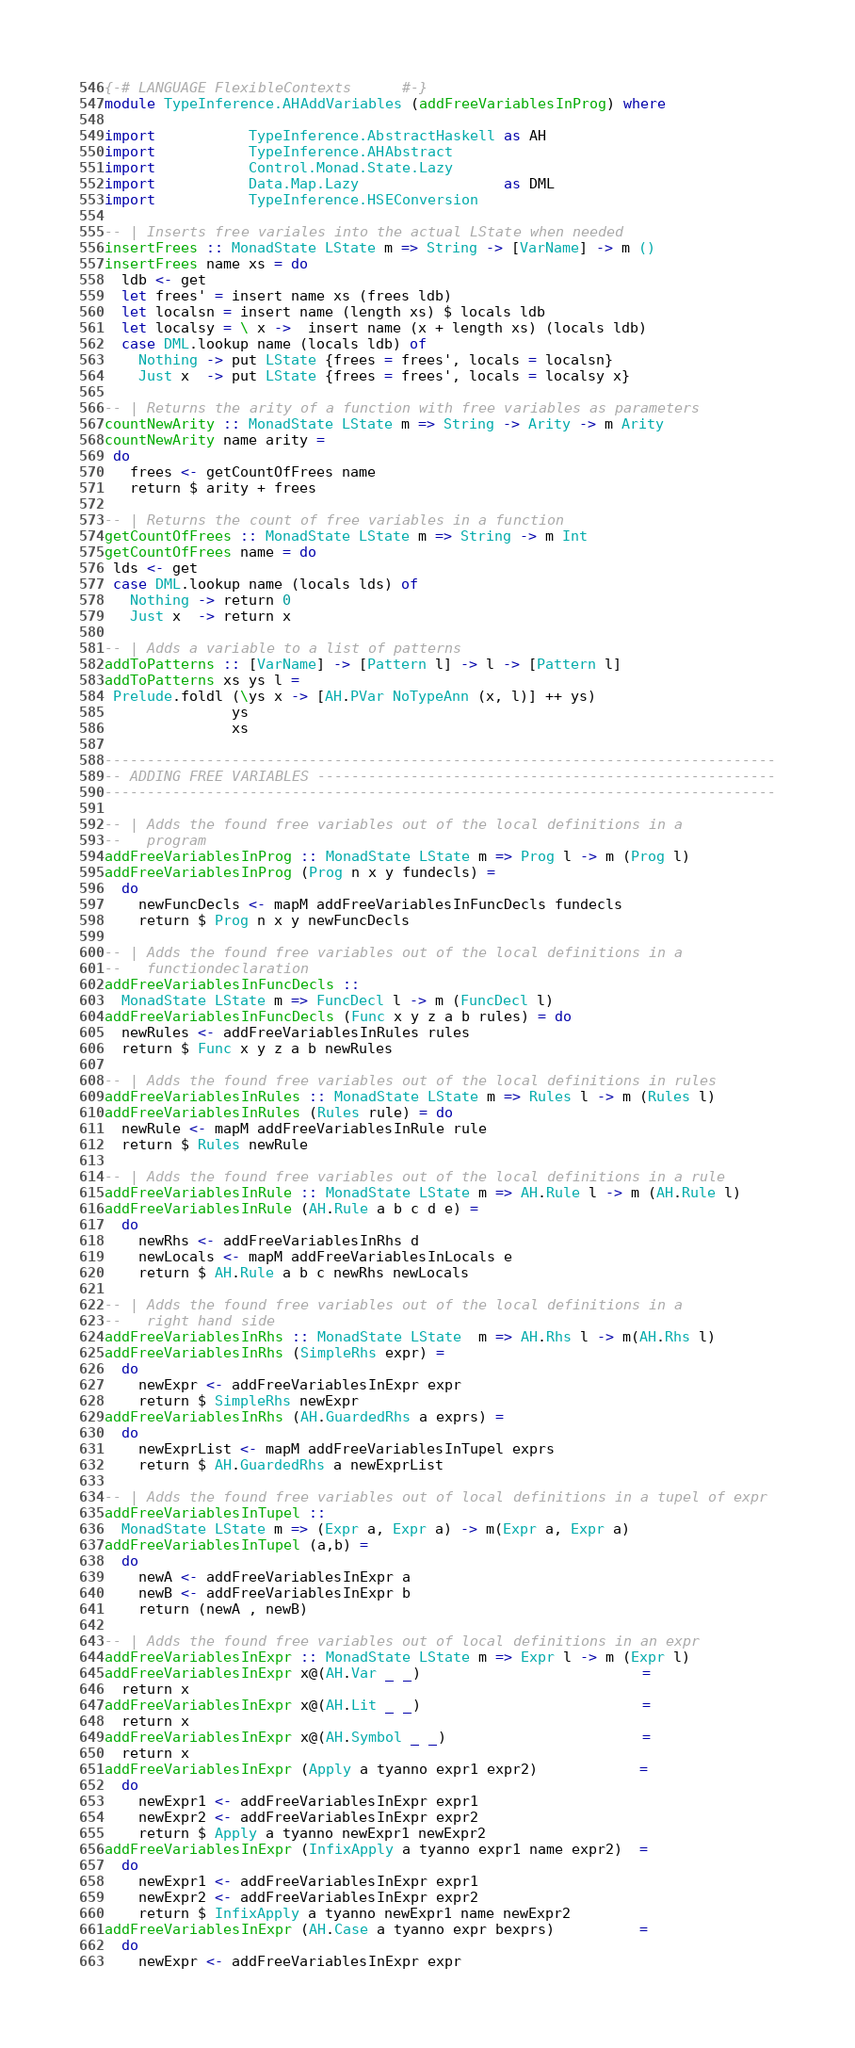Convert code to text. <code><loc_0><loc_0><loc_500><loc_500><_Haskell_>{-# LANGUAGE FlexibleContexts      #-}
module TypeInference.AHAddVariables (addFreeVariablesInProg) where

import           TypeInference.AbstractHaskell as AH
import           TypeInference.AHAbstract
import           Control.Monad.State.Lazy
import           Data.Map.Lazy                 as DML
import           TypeInference.HSEConversion

-- | Inserts free variales into the actual LState when needed
insertFrees :: MonadState LState m => String -> [VarName] -> m ()
insertFrees name xs = do
  ldb <- get
  let frees' = insert name xs (frees ldb)
  let localsn = insert name (length xs) $ locals ldb
  let localsy = \ x ->  insert name (x + length xs) (locals ldb)
  case DML.lookup name (locals ldb) of
    Nothing -> put LState {frees = frees', locals = localsn}
    Just x  -> put LState {frees = frees', locals = localsy x}

-- | Returns the arity of a function with free variables as parameters
countNewArity :: MonadState LState m => String -> Arity -> m Arity
countNewArity name arity =
 do
   frees <- getCountOfFrees name
   return $ arity + frees

-- | Returns the count of free variables in a function
getCountOfFrees :: MonadState LState m => String -> m Int
getCountOfFrees name = do
 lds <- get
 case DML.lookup name (locals lds) of
   Nothing -> return 0
   Just x  -> return x

-- | Adds a variable to a list of patterns
addToPatterns :: [VarName] -> [Pattern l] -> l -> [Pattern l]
addToPatterns xs ys l =
 Prelude.foldl (\ys x -> [AH.PVar NoTypeAnn (x, l)] ++ ys)
               ys
               xs

-------------------------------------------------------------------------------
-- ADDING FREE VARIABLES ------------------------------------------------------
-------------------------------------------------------------------------------

-- | Adds the found free variables out of the local definitions in a
--   program
addFreeVariablesInProg :: MonadState LState m => Prog l -> m (Prog l)
addFreeVariablesInProg (Prog n x y fundecls) =
  do
    newFuncDecls <- mapM addFreeVariablesInFuncDecls fundecls
    return $ Prog n x y newFuncDecls

-- | Adds the found free variables out of the local definitions in a
--   functiondeclaration
addFreeVariablesInFuncDecls ::
  MonadState LState m => FuncDecl l -> m (FuncDecl l)
addFreeVariablesInFuncDecls (Func x y z a b rules) = do
  newRules <- addFreeVariablesInRules rules
  return $ Func x y z a b newRules

-- | Adds the found free variables out of the local definitions in rules
addFreeVariablesInRules :: MonadState LState m => Rules l -> m (Rules l)
addFreeVariablesInRules (Rules rule) = do
  newRule <- mapM addFreeVariablesInRule rule
  return $ Rules newRule

-- | Adds the found free variables out of the local definitions in a rule
addFreeVariablesInRule :: MonadState LState m => AH.Rule l -> m (AH.Rule l)
addFreeVariablesInRule (AH.Rule a b c d e) =
  do
    newRhs <- addFreeVariablesInRhs d
    newLocals <- mapM addFreeVariablesInLocals e
    return $ AH.Rule a b c newRhs newLocals

-- | Adds the found free variables out of the local definitions in a
--   right hand side
addFreeVariablesInRhs :: MonadState LState  m => AH.Rhs l -> m(AH.Rhs l)
addFreeVariablesInRhs (SimpleRhs expr) =
  do
    newExpr <- addFreeVariablesInExpr expr
    return $ SimpleRhs newExpr
addFreeVariablesInRhs (AH.GuardedRhs a exprs) =
  do
    newExprList <- mapM addFreeVariablesInTupel exprs
    return $ AH.GuardedRhs a newExprList

-- | Adds the found free variables out of local definitions in a tupel of expr
addFreeVariablesInTupel ::
  MonadState LState m => (Expr a, Expr a) -> m(Expr a, Expr a)
addFreeVariablesInTupel (a,b) =
  do
    newA <- addFreeVariablesInExpr a
    newB <- addFreeVariablesInExpr b
    return (newA , newB)

-- | Adds the found free variables out of local definitions in an expr
addFreeVariablesInExpr :: MonadState LState m => Expr l -> m (Expr l)
addFreeVariablesInExpr x@(AH.Var _ _)                          =
  return x
addFreeVariablesInExpr x@(AH.Lit _ _)                          =
  return x
addFreeVariablesInExpr x@(AH.Symbol _ _)                       =
  return x
addFreeVariablesInExpr (Apply a tyanno expr1 expr2)            =
  do
    newExpr1 <- addFreeVariablesInExpr expr1
    newExpr2 <- addFreeVariablesInExpr expr2
    return $ Apply a tyanno newExpr1 newExpr2
addFreeVariablesInExpr (InfixApply a tyanno expr1 name expr2)  =
  do
    newExpr1 <- addFreeVariablesInExpr expr1
    newExpr2 <- addFreeVariablesInExpr expr2
    return $ InfixApply a tyanno newExpr1 name newExpr2
addFreeVariablesInExpr (AH.Case a tyanno expr bexprs)          =
  do
    newExpr <- addFreeVariablesInExpr expr</code> 